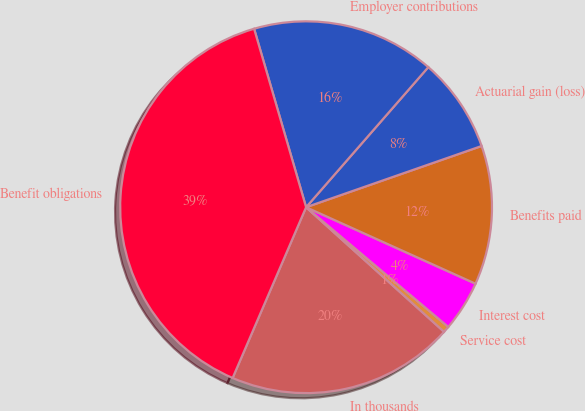Convert chart. <chart><loc_0><loc_0><loc_500><loc_500><pie_chart><fcel>In thousands<fcel>Service cost<fcel>Interest cost<fcel>Benefits paid<fcel>Actuarial gain (loss)<fcel>Employer contributions<fcel>Benefit obligations<nl><fcel>19.78%<fcel>0.55%<fcel>4.39%<fcel>12.09%<fcel>8.24%<fcel>15.93%<fcel>39.02%<nl></chart> 